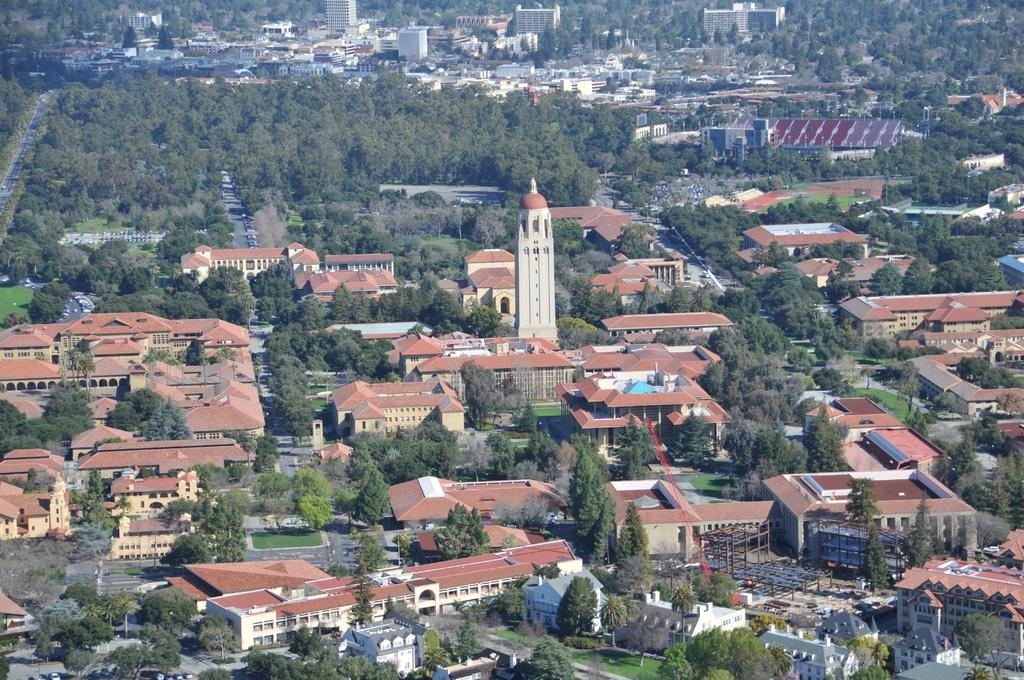What type of structures can be seen in the image? There are many buildings, houses, and a tower in the image. What type of natural elements can be seen in the image? There are trees in the image. What type of man-made structures can be seen in the image? There are roads in the image. What type of transportation can be seen in the image? There are vehicles in the image. What type of construction materials can be seen in the image? There are rods in the image. Where is the cave located in the image? There is no cave present in the image. What is the value of the hill in the image? There is no hill present in the image, and therefore no value can be assigned to it. 